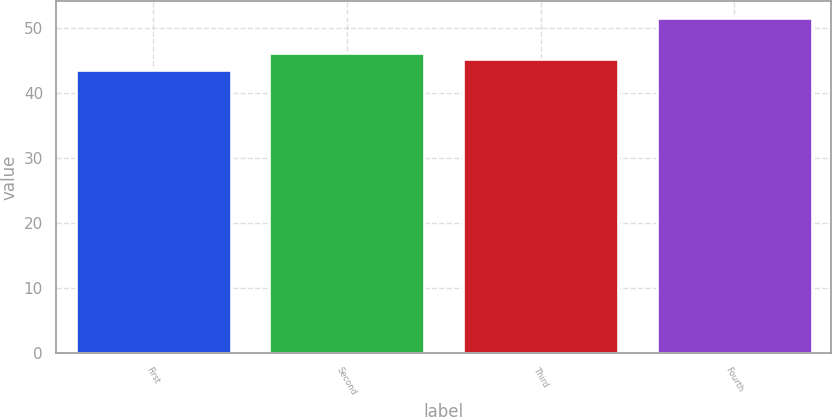Convert chart to OTSL. <chart><loc_0><loc_0><loc_500><loc_500><bar_chart><fcel>First<fcel>Second<fcel>Third<fcel>Fourth<nl><fcel>43.63<fcel>46.12<fcel>45.32<fcel>51.61<nl></chart> 